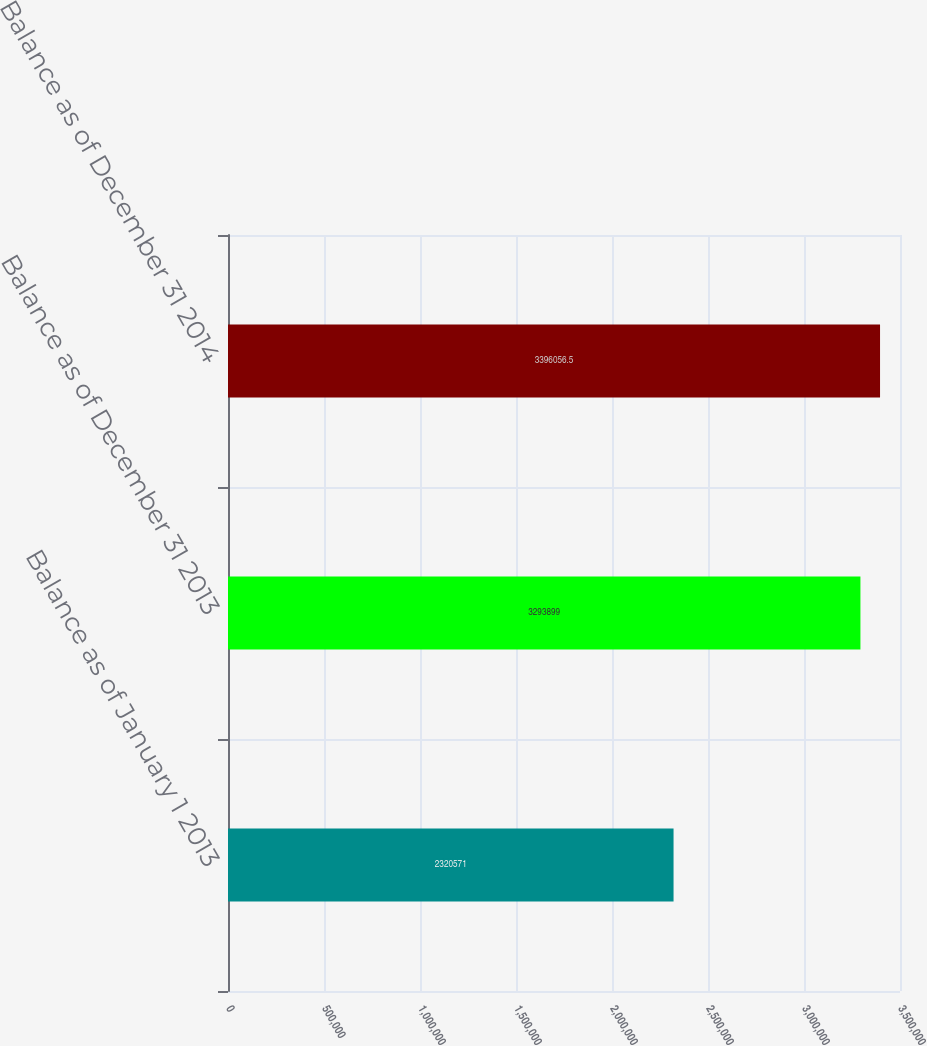Convert chart to OTSL. <chart><loc_0><loc_0><loc_500><loc_500><bar_chart><fcel>Balance as of January 1 2013<fcel>Balance as of December 31 2013<fcel>Balance as of December 31 2014<nl><fcel>2.32057e+06<fcel>3.2939e+06<fcel>3.39606e+06<nl></chart> 